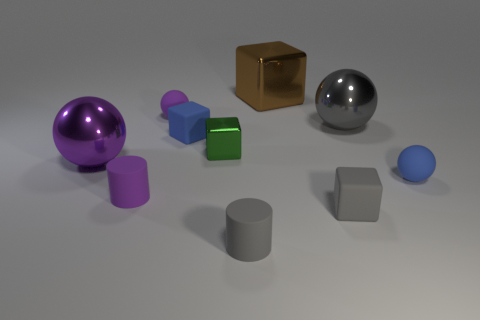Subtract all cylinders. How many objects are left? 8 Subtract all tiny rubber spheres. Subtract all tiny blue spheres. How many objects are left? 7 Add 3 brown metal blocks. How many brown metal blocks are left? 4 Add 7 tiny purple spheres. How many tiny purple spheres exist? 8 Subtract 0 red cylinders. How many objects are left? 10 